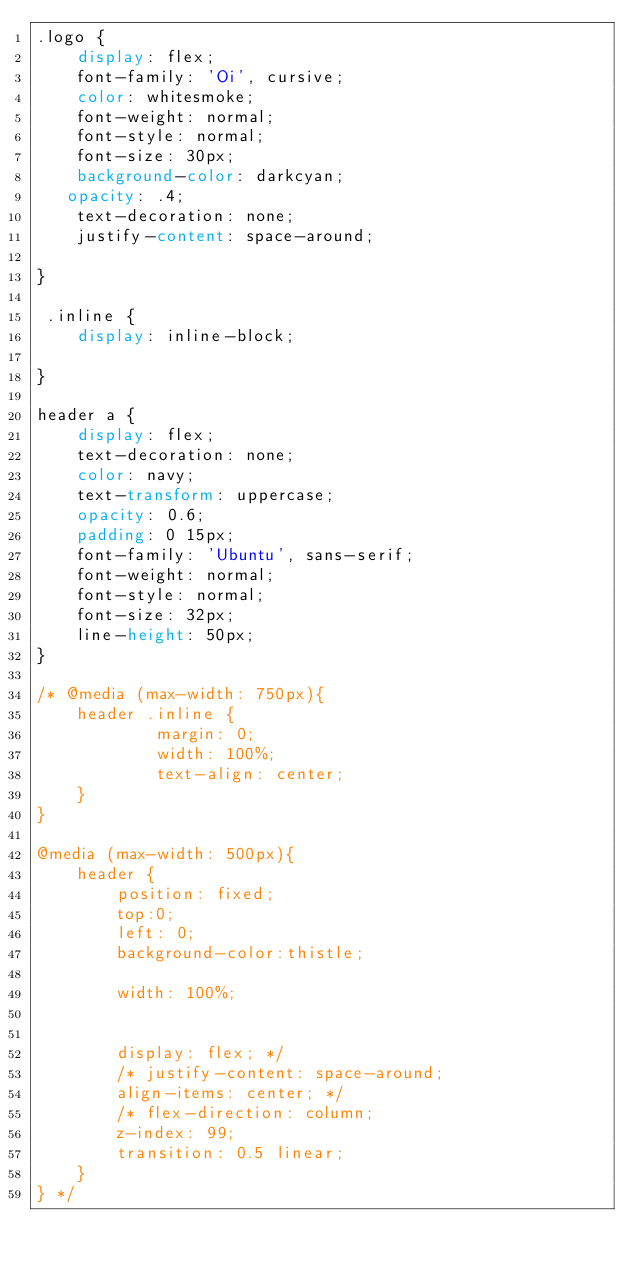Convert code to text. <code><loc_0><loc_0><loc_500><loc_500><_CSS_>.logo {
    display: flex;
    font-family: 'Oi', cursive;
    color: whitesmoke;
    font-weight: normal;
    font-style: normal;
    font-size: 30px;
    background-color: darkcyan;
   opacity: .4;
    text-decoration: none;
    justify-content: space-around;

}

 .inline {
    display: inline-block;
    
}

header a {
    display: flex;
    text-decoration: none;
    color: navy;
    text-transform: uppercase;
    opacity: 0.6;
    padding: 0 15px;
    font-family: 'Ubuntu', sans-serif;
    font-weight: normal;
    font-style: normal;
    font-size: 32px;
    line-height: 50px;
}

/* @media (max-width: 750px){
    header .inline {
            margin: 0;
            width: 100%;
            text-align: center;
    }
}

@media (max-width: 500px){
    header {
        position: fixed;
        top:0;
        left: 0; 
        background-color:thistle; 
       
        width: 100%;
       
        
        display: flex; */
        /* justify-content: space-around;
        align-items: center; */
        /* flex-direction: column;
        z-index: 99;
        transition: 0.5 linear; 
    }
} */





</code> 